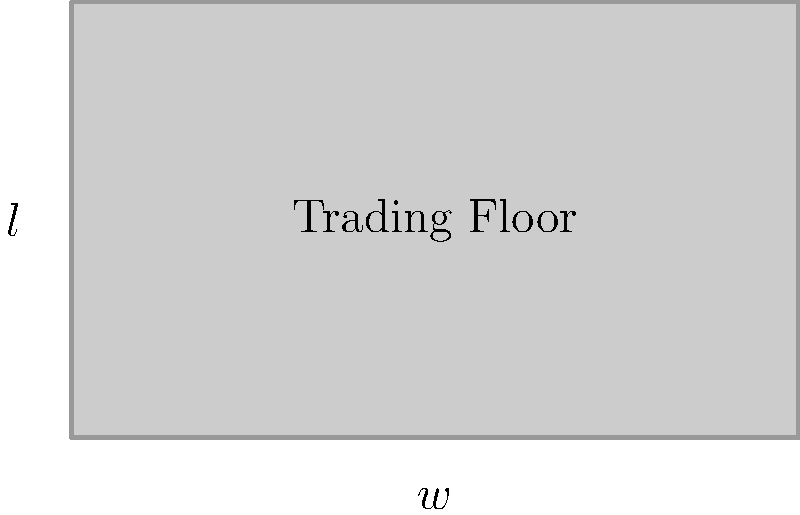As a financial blogger, you're analyzing the design of a new trading floor. The floor needs to be rectangular with a perimeter of 100 meters. What dimensions (length and width) would maximize the floor area, potentially increasing trading efficiency? Assume that the cost per square meter is constant. Let's approach this step-by-step:

1) Let $l$ be the length and $w$ be the width of the trading floor.

2) Given that the perimeter is 100 meters, we can write:
   $2l + 2w = 100$
   
3) Solving for $l$:
   $l = 50 - w$

4) The area $A$ of the rectangle is given by:
   $A = lw = (50-w)w = 50w - w^2$

5) To maximize the area, we need to find the maximum of this quadratic function. In calculus, we'd differentiate and set to zero, but we can also reason that the maximum of a parabola occurs at the average of its roots.

6) The roots of $50w - w^2 = 0$ are $w=0$ and $w=50$.

7) Therefore, the maximum occurs at $w = (0+50)/2 = 25$.

8) If $w = 25$, then $l = 50 - 25 = 25$ as well.

This result aligns with the mathematical principle that a square maximizes the area for a given perimeter among all rectangles.
Answer: Length = 25 meters, Width = 25 meters 